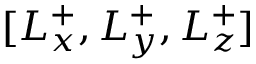Convert formula to latex. <formula><loc_0><loc_0><loc_500><loc_500>[ L _ { x } ^ { + } , L _ { y } ^ { + } , L _ { z } ^ { + } ]</formula> 